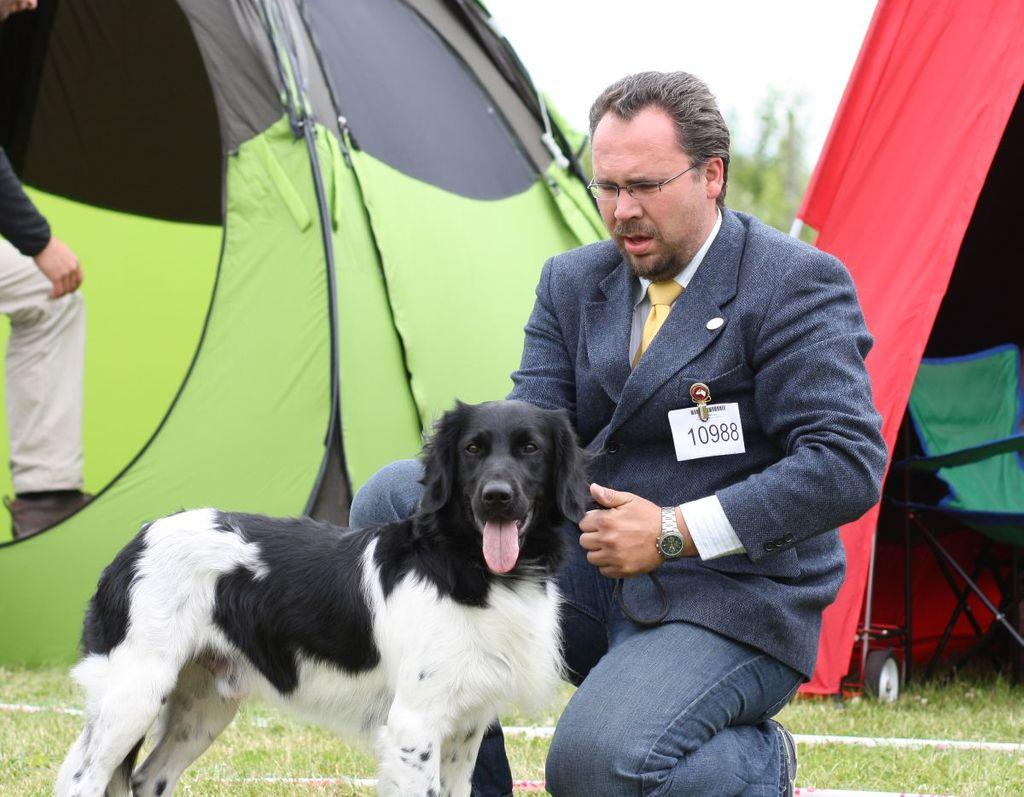How many people are in the image? There are a few people in the image. What can be seen under the people's feet in the image? The ground is visible in the image. What type of animal is in the image? There is an animal in the image. What type of vegetation is present in the image? There is grass in the image. What type of furniture is in the image? There is a chair in the image. How would you describe the background of the image? The background of the image is blurred. What type of cable is being used by the animal in the image? There is no cable present in the image; it features a few people, an animal, a chair, grass, and a blurred background. 